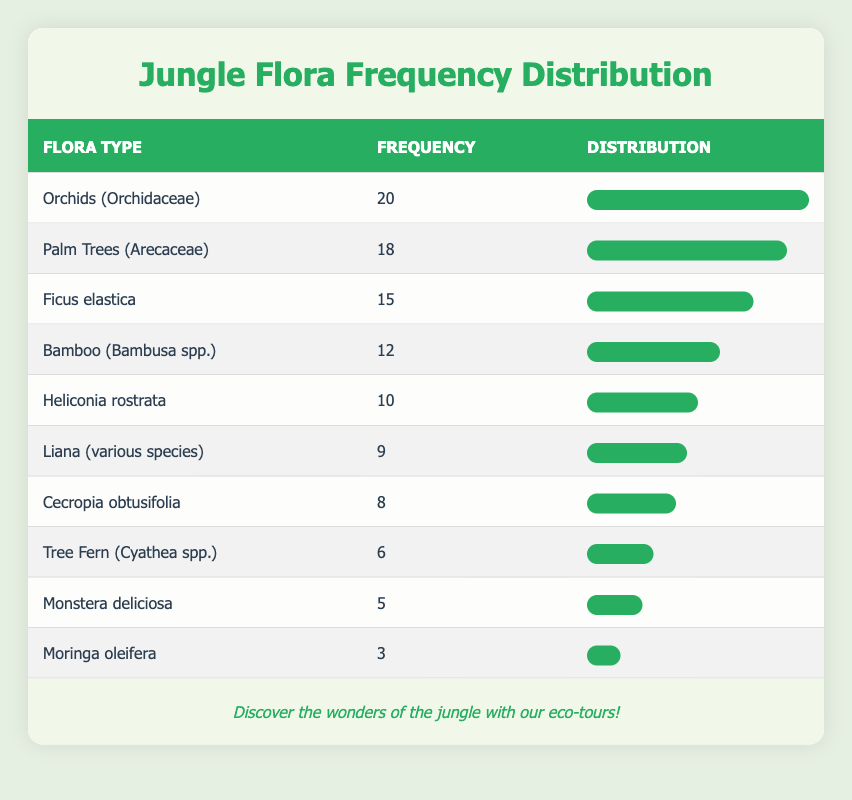What is the most frequently identified flora type during the guided jungle walks? The table shows that the flora type "Orchids (Orchidaceae)" has the highest frequency of 20, indicating that it is the most frequently identified flora type.
Answer: 20 Which flora type is identified the least frequently, and how many times is it identified? From the table, "Moringa oleifera" is identified the least frequently with a frequency of 3, which is the lowest among all the flora types listed.
Answer: Moringa oleifera, 3 What is the combined frequency of "Ficus elastica" and "Palm Trees (Arecaceae)"? The frequency of "Ficus elastica" is 15 and "Palm Trees (Arecaceae)" is 18. Adding these together gives 15 + 18 = 33.
Answer: 33 Is the frequency of "Tree Fern (Cyathea spp.)" greater than that of "Cecropia obtusifolia"? "Tree Fern (Cyathea spp.)" has a frequency of 6, while "Cecropia obtusifolia" has a frequency of 8. Since 6 is less than 8, the answer is no.
Answer: No How many flora types are identified with a frequency of 10 or more? The identified flora types that have a frequency of 10 or more are "Orchids (Orchidaceae)", "Palm Trees (Arecaceae)", "Ficus elastica", "Bamboo (Bambusa spp.)", and "Heliconia rostrata". There are 5 flora types in total meeting this criterion.
Answer: 5 If we consider just the top three flora types by frequency, what is their total frequency? The top three flora types are "Orchids (Orchidaceae)" with 20, "Palm Trees (Arecaceae)" with 18, and "Ficus elastica" with 15. Summing these gives: 20 + 18 + 15 = 53.
Answer: 53 Is there any flora type with a frequency of exactly 5? Looking at the table, "Monstera deliciosa" has a frequency of 5. Therefore, there is indeed a flora type with this frequency.
Answer: Yes What is the average frequency of all the flora types listed in the table? To find the average, we first sum the frequencies: 20 + 18 + 15 + 12 + 10 + 9 + 8 + 6 + 5 + 3 = 106. There are 10 flora types, so the average is 106/10 = 10.6.
Answer: 10.6 